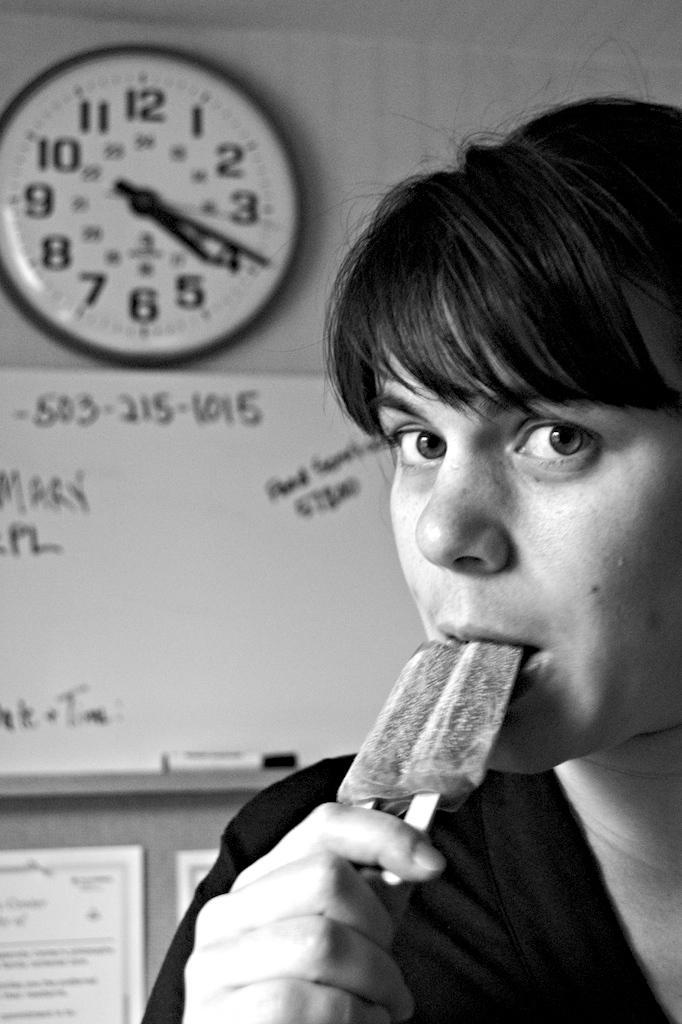Please provide a concise description of this image. In this picture I can see there is a woman eating ice cream and in the backdrop there is a white board and a marker and there is a clock and few papers pasted on the wall. 